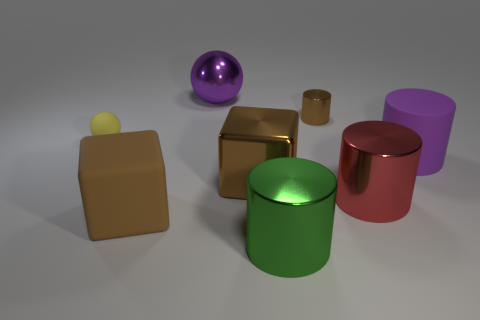What is the color of the big cylinder that is made of the same material as the small yellow ball?
Your answer should be compact. Purple. How many other big things have the same material as the red object?
Your answer should be very brief. 3. How many small gray objects are there?
Your answer should be compact. 0. There is a large cube that is on the right side of the brown matte cube; is it the same color as the tiny shiny thing that is to the right of the large purple sphere?
Offer a terse response. Yes. There is a small brown object; how many small brown cylinders are right of it?
Offer a terse response. 0. There is a big ball that is the same color as the large matte cylinder; what is its material?
Offer a very short reply. Metal. Are there any other things of the same shape as the yellow object?
Your response must be concise. Yes. Is the purple thing on the left side of the tiny metallic object made of the same material as the large red thing that is in front of the rubber cylinder?
Your answer should be very brief. Yes. How big is the cylinder behind the yellow rubber sphere that is to the left of the brown shiny object right of the green object?
Provide a short and direct response. Small. What material is the sphere that is the same size as the rubber block?
Provide a succinct answer. Metal. 